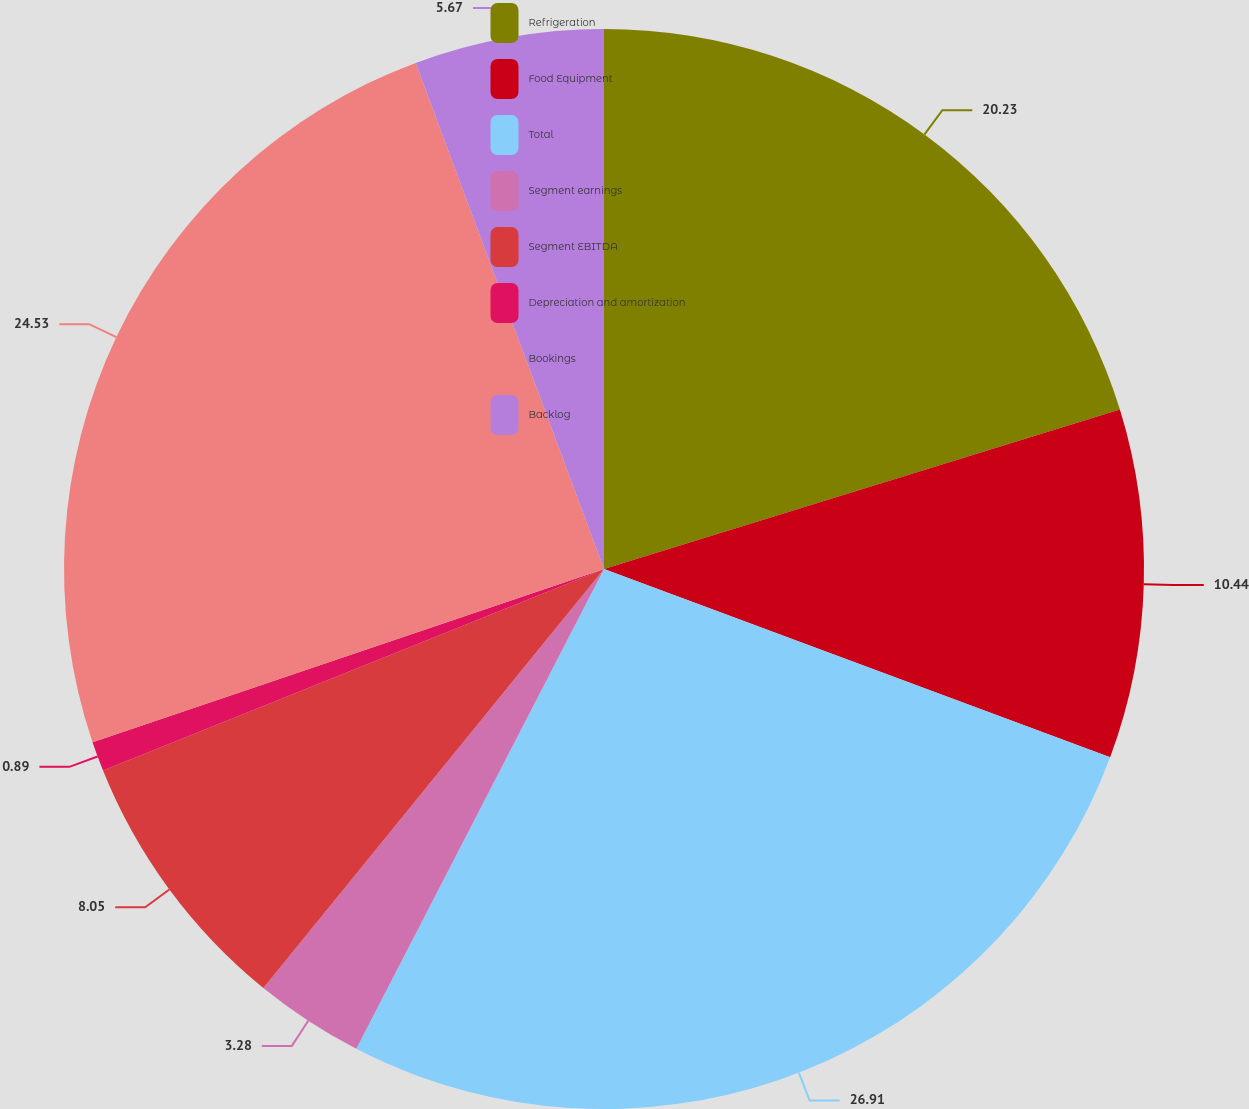Convert chart to OTSL. <chart><loc_0><loc_0><loc_500><loc_500><pie_chart><fcel>Refrigeration<fcel>Food Equipment<fcel>Total<fcel>Segment earnings<fcel>Segment EBITDA<fcel>Depreciation and amortization<fcel>Bookings<fcel>Backlog<nl><fcel>20.23%<fcel>10.44%<fcel>26.92%<fcel>3.28%<fcel>8.05%<fcel>0.89%<fcel>24.53%<fcel>5.67%<nl></chart> 